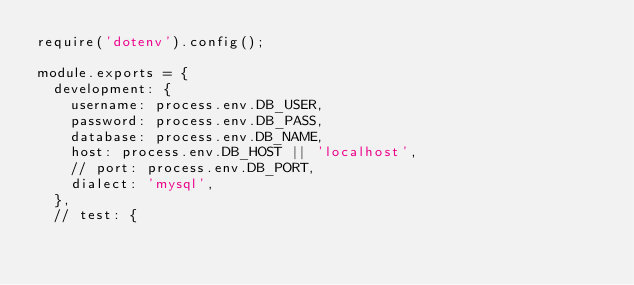Convert code to text. <code><loc_0><loc_0><loc_500><loc_500><_JavaScript_>require('dotenv').config();

module.exports = {
  development: {
    username: process.env.DB_USER,
    password: process.env.DB_PASS,
    database: process.env.DB_NAME,
    host: process.env.DB_HOST || 'localhost',
    // port: process.env.DB_PORT,
    dialect: 'mysql',
  },
  // test: {</code> 